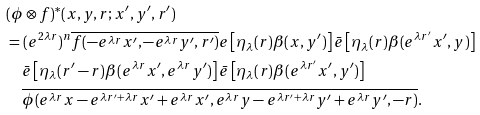Convert formula to latex. <formula><loc_0><loc_0><loc_500><loc_500>& ( \phi \otimes f ) ^ { * } ( x , y , r ; x ^ { \prime } , y ^ { \prime } , r ^ { \prime } ) \\ & = ( e ^ { 2 \lambda r } ) ^ { n } \overline { f ( - e ^ { \lambda r } x ^ { \prime } , - e ^ { \lambda r } y ^ { \prime } , r ^ { \prime } ) } e \left [ \eta _ { \lambda } ( r ) \beta ( x , y ^ { \prime } ) \right ] \bar { e } \left [ \eta _ { \lambda } ( r ) \beta ( e ^ { \lambda r ^ { \prime } } x ^ { \prime } , y ) \right ] \\ & \quad \bar { e } \left [ \eta _ { \lambda } ( r ^ { \prime } - r ) \beta ( e ^ { \lambda r } x ^ { \prime } , e ^ { \lambda r } y ^ { \prime } ) \right ] \bar { e } \left [ \eta _ { \lambda } ( r ) \beta ( e ^ { \lambda r ^ { \prime } } x ^ { \prime } , y ^ { \prime } ) \right ] \\ & \quad \overline { \phi ( e ^ { \lambda r } x - e ^ { \lambda r ^ { \prime } + \lambda r } x ^ { \prime } + e ^ { \lambda r } x ^ { \prime } , e ^ { \lambda r } y - e ^ { \lambda r ^ { \prime } + \lambda r } y ^ { \prime } + e ^ { \lambda r } y ^ { \prime } , - r ) } .</formula> 